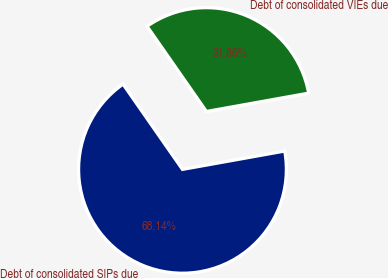Convert chart. <chart><loc_0><loc_0><loc_500><loc_500><pie_chart><fcel>Debt of consolidated SIPs due<fcel>Debt of consolidated VIEs due<nl><fcel>68.14%<fcel>31.86%<nl></chart> 